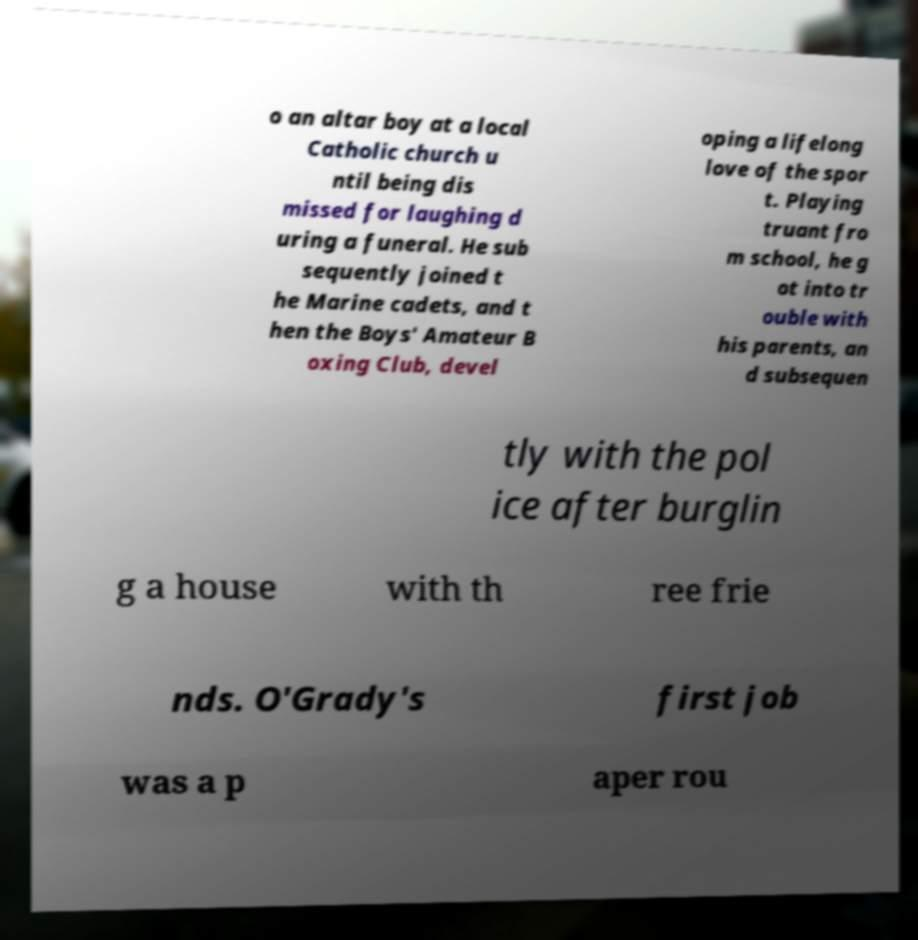There's text embedded in this image that I need extracted. Can you transcribe it verbatim? o an altar boy at a local Catholic church u ntil being dis missed for laughing d uring a funeral. He sub sequently joined t he Marine cadets, and t hen the Boys' Amateur B oxing Club, devel oping a lifelong love of the spor t. Playing truant fro m school, he g ot into tr ouble with his parents, an d subsequen tly with the pol ice after burglin g a house with th ree frie nds. O'Grady's first job was a p aper rou 